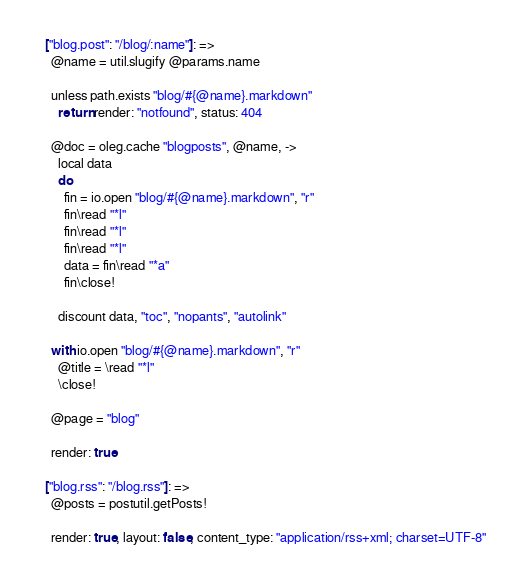<code> <loc_0><loc_0><loc_500><loc_500><_MoonScript_>
  ["blog.post": "/blog/:name"]: =>
    @name = util.slugify @params.name

    unless path.exists "blog/#{@name}.markdown"
      return render: "notfound", status: 404

    @doc = oleg.cache "blogposts", @name, ->
      local data
      do
        fin = io.open "blog/#{@name}.markdown", "r"
        fin\read "*l"
        fin\read "*l"
        fin\read "*l"
        data = fin\read "*a"
        fin\close!

      discount data, "toc", "nopants", "autolink"

    with io.open "blog/#{@name}.markdown", "r"
      @title = \read "*l"
      \close!

    @page = "blog"

    render: true

  ["blog.rss": "/blog.rss"]: =>
    @posts = postutil.getPosts!

    render: true, layout: false, content_type: "application/rss+xml; charset=UTF-8"</code> 